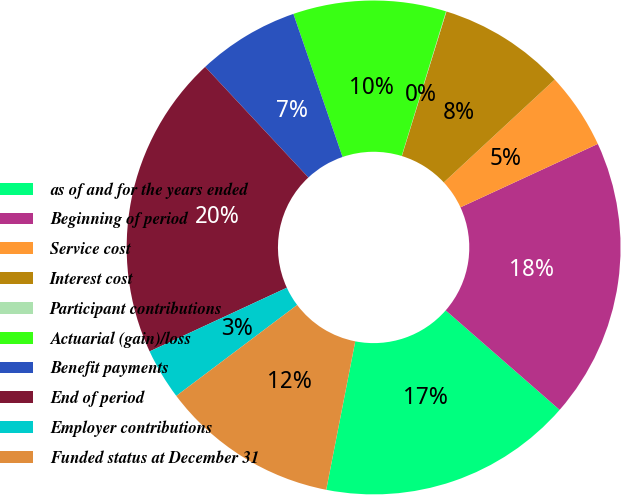Convert chart. <chart><loc_0><loc_0><loc_500><loc_500><pie_chart><fcel>as of and for the years ended<fcel>Beginning of period<fcel>Service cost<fcel>Interest cost<fcel>Participant contributions<fcel>Actuarial (gain)/loss<fcel>Benefit payments<fcel>End of period<fcel>Employer contributions<fcel>Funded status at December 31<nl><fcel>16.65%<fcel>18.31%<fcel>5.01%<fcel>8.34%<fcel>0.03%<fcel>10.0%<fcel>6.68%<fcel>19.97%<fcel>3.35%<fcel>11.66%<nl></chart> 